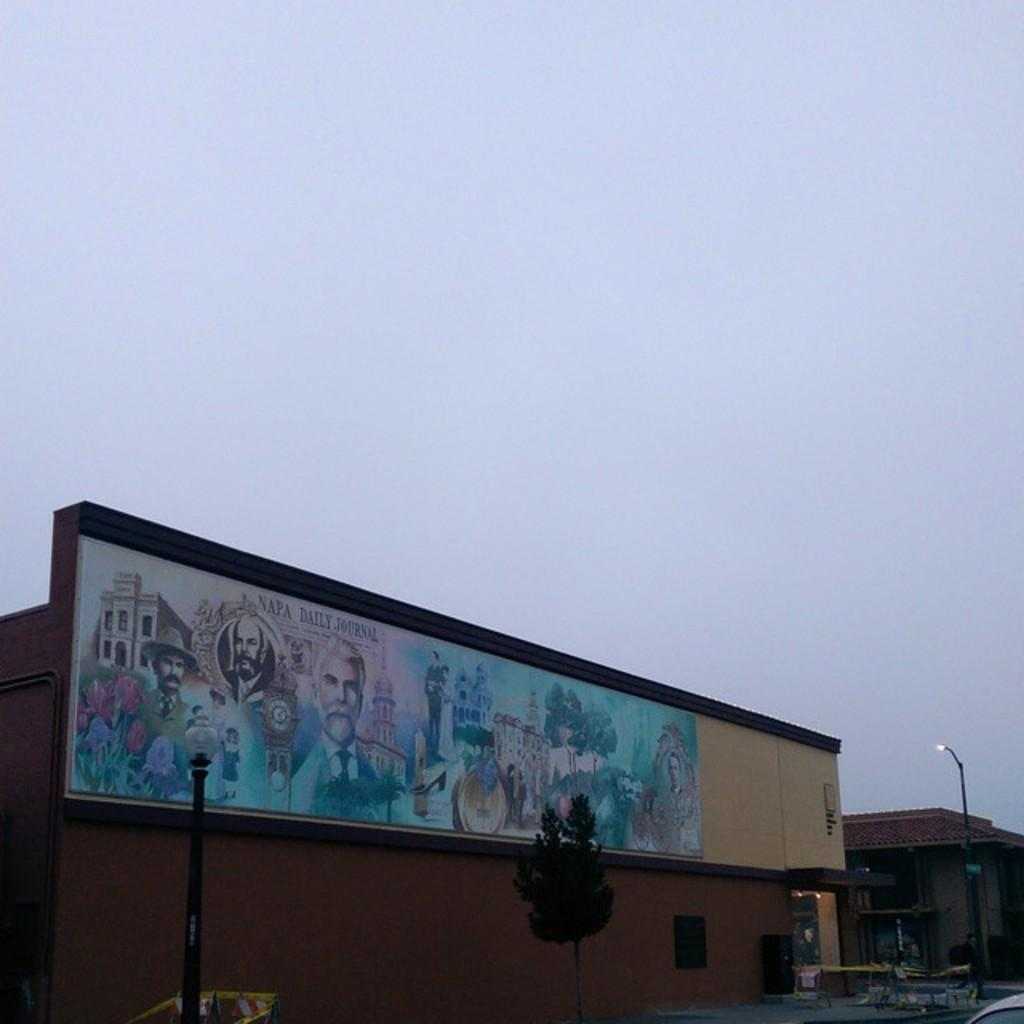<image>
Describe the image concisely. A large mural on the side of a building says Napa Daily Journal. 